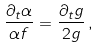<formula> <loc_0><loc_0><loc_500><loc_500>\frac { \partial _ { t } \alpha } { \alpha f } = \frac { \partial _ { t } g } { 2 g } \, ,</formula> 